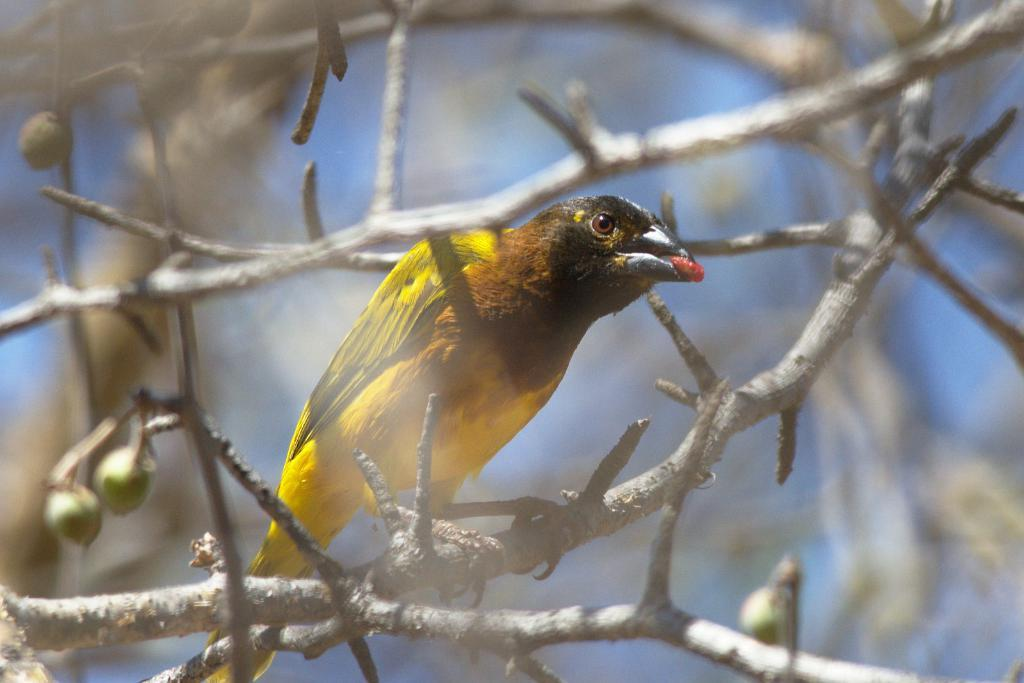What type of animal is in the image? There is a bird in the image. Where is the bird located? The bird is standing on a branch. What is the branch a part of? The branch appears to be part of a tree. What can be seen hanging from the tree in the image? There are small fruits hanging from the stem in the image. How would you describe the background of the image? The background of the image is blurry. What type of representative is present in the image? There is no representative present in the image; it features a bird standing on a branch of a tree with small fruits hanging from the stem. 